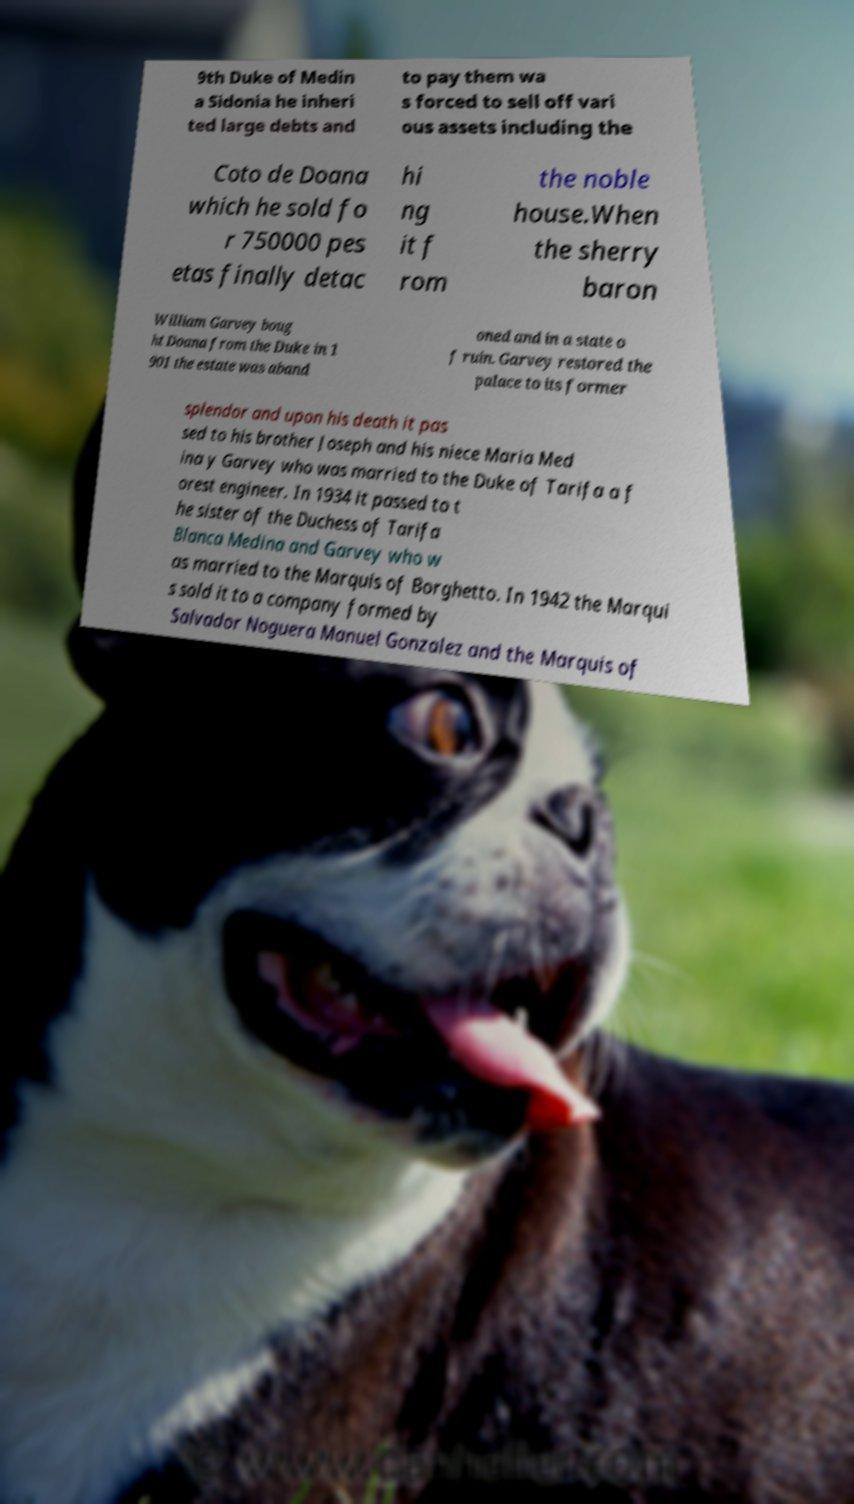Could you assist in decoding the text presented in this image and type it out clearly? 9th Duke of Medin a Sidonia he inheri ted large debts and to pay them wa s forced to sell off vari ous assets including the Coto de Doana which he sold fo r 750000 pes etas finally detac hi ng it f rom the noble house.When the sherry baron William Garvey boug ht Doana from the Duke in 1 901 the estate was aband oned and in a state o f ruin. Garvey restored the palace to its former splendor and upon his death it pas sed to his brother Joseph and his niece Maria Med ina y Garvey who was married to the Duke of Tarifa a f orest engineer. In 1934 it passed to t he sister of the Duchess of Tarifa Blanca Medina and Garvey who w as married to the Marquis of Borghetto. In 1942 the Marqui s sold it to a company formed by Salvador Noguera Manuel Gonzalez and the Marquis of 